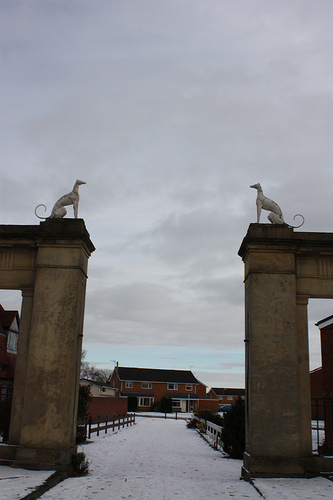<image>
Is the dog behind the snow? No. The dog is not behind the snow. From this viewpoint, the dog appears to be positioned elsewhere in the scene. 